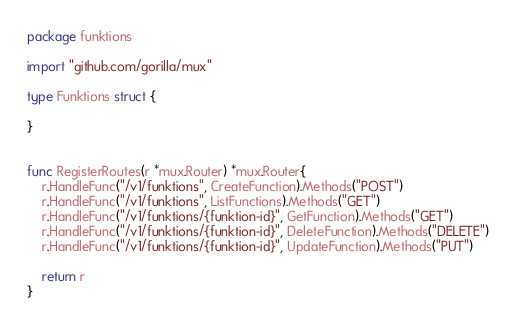<code> <loc_0><loc_0><loc_500><loc_500><_Go_>package funktions

import "github.com/gorilla/mux"

type Funktions struct {

}


func RegisterRoutes(r *mux.Router) *mux.Router{
	r.HandleFunc("/v1/funktions", CreateFunction).Methods("POST")
	r.HandleFunc("/v1/funktions", ListFunctions).Methods("GET")
	r.HandleFunc("/v1/funktions/{funktion-id}", GetFunction).Methods("GET")
	r.HandleFunc("/v1/funktions/{funktion-id}", DeleteFunction).Methods("DELETE")
	r.HandleFunc("/v1/funktions/{funktion-id}", UpdateFunction).Methods("PUT")

	return r
}
</code> 